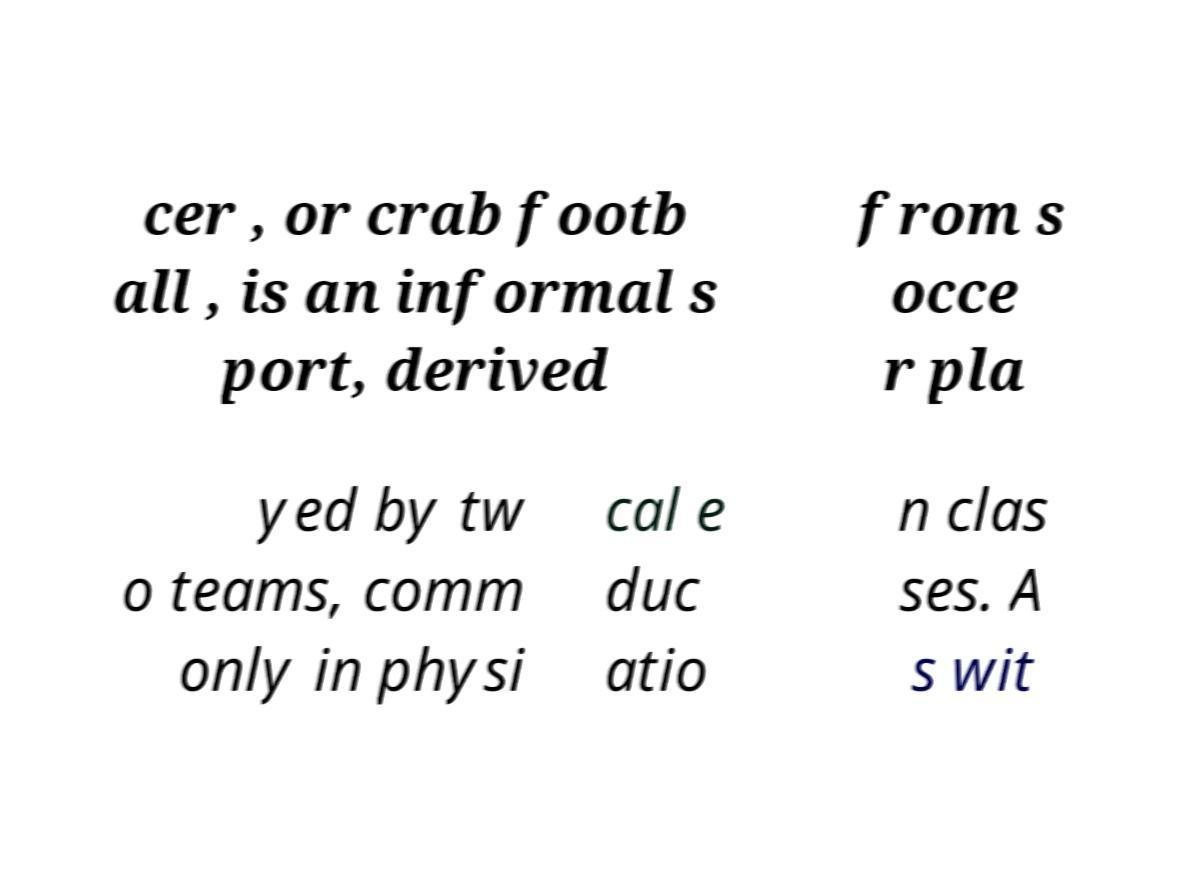Can you accurately transcribe the text from the provided image for me? cer , or crab footb all , is an informal s port, derived from s occe r pla yed by tw o teams, comm only in physi cal e duc atio n clas ses. A s wit 